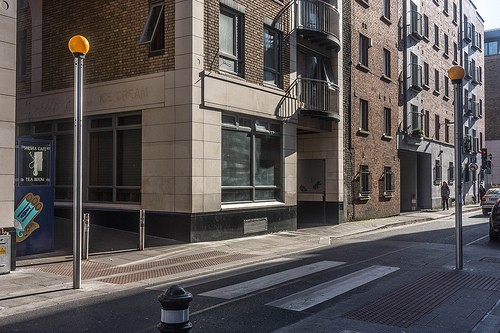<image>
Is the balcony above the sidewalk? Yes. The balcony is positioned above the sidewalk in the vertical space, higher up in the scene. 